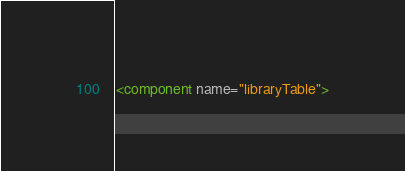<code> <loc_0><loc_0><loc_500><loc_500><_XML_><component name="libraryTable"></code> 